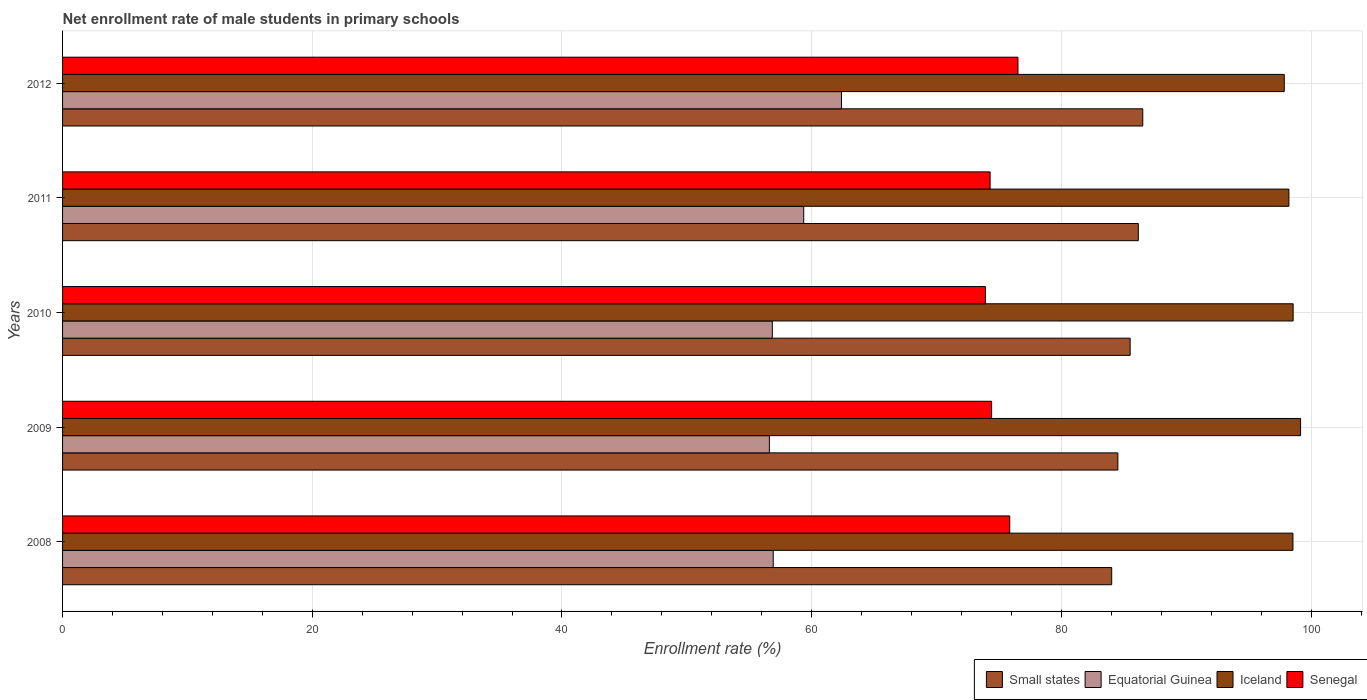How many different coloured bars are there?
Your answer should be very brief. 4. How many groups of bars are there?
Keep it short and to the point. 5. What is the label of the 3rd group of bars from the top?
Your response must be concise. 2010. In how many cases, is the number of bars for a given year not equal to the number of legend labels?
Give a very brief answer. 0. What is the net enrollment rate of male students in primary schools in Small states in 2010?
Ensure brevity in your answer.  85.51. Across all years, what is the maximum net enrollment rate of male students in primary schools in Equatorial Guinea?
Offer a terse response. 62.39. Across all years, what is the minimum net enrollment rate of male students in primary schools in Iceland?
Your answer should be very brief. 97.85. What is the total net enrollment rate of male students in primary schools in Iceland in the graph?
Provide a succinct answer. 492.33. What is the difference between the net enrollment rate of male students in primary schools in Iceland in 2008 and that in 2009?
Offer a very short reply. -0.61. What is the difference between the net enrollment rate of male students in primary schools in Equatorial Guinea in 2010 and the net enrollment rate of male students in primary schools in Iceland in 2008?
Give a very brief answer. -41.7. What is the average net enrollment rate of male students in primary schools in Iceland per year?
Your answer should be compact. 98.47. In the year 2011, what is the difference between the net enrollment rate of male students in primary schools in Equatorial Guinea and net enrollment rate of male students in primary schools in Small states?
Keep it short and to the point. -26.8. What is the ratio of the net enrollment rate of male students in primary schools in Equatorial Guinea in 2008 to that in 2012?
Offer a very short reply. 0.91. Is the net enrollment rate of male students in primary schools in Equatorial Guinea in 2009 less than that in 2011?
Give a very brief answer. Yes. What is the difference between the highest and the second highest net enrollment rate of male students in primary schools in Iceland?
Offer a terse response. 0.6. What is the difference between the highest and the lowest net enrollment rate of male students in primary schools in Small states?
Ensure brevity in your answer.  2.49. In how many years, is the net enrollment rate of male students in primary schools in Small states greater than the average net enrollment rate of male students in primary schools in Small states taken over all years?
Keep it short and to the point. 3. Is the sum of the net enrollment rate of male students in primary schools in Iceland in 2010 and 2011 greater than the maximum net enrollment rate of male students in primary schools in Senegal across all years?
Your response must be concise. Yes. What does the 1st bar from the top in 2011 represents?
Ensure brevity in your answer.  Senegal. What does the 4th bar from the bottom in 2010 represents?
Offer a terse response. Senegal. Is it the case that in every year, the sum of the net enrollment rate of male students in primary schools in Small states and net enrollment rate of male students in primary schools in Iceland is greater than the net enrollment rate of male students in primary schools in Equatorial Guinea?
Offer a terse response. Yes. Are all the bars in the graph horizontal?
Keep it short and to the point. Yes. What is the difference between two consecutive major ticks on the X-axis?
Ensure brevity in your answer.  20. Does the graph contain any zero values?
Your answer should be very brief. No. How are the legend labels stacked?
Your answer should be compact. Horizontal. What is the title of the graph?
Give a very brief answer. Net enrollment rate of male students in primary schools. What is the label or title of the X-axis?
Offer a terse response. Enrollment rate (%). What is the label or title of the Y-axis?
Your response must be concise. Years. What is the Enrollment rate (%) of Small states in 2008?
Keep it short and to the point. 84.03. What is the Enrollment rate (%) of Equatorial Guinea in 2008?
Ensure brevity in your answer.  56.92. What is the Enrollment rate (%) in Iceland in 2008?
Provide a short and direct response. 98.54. What is the Enrollment rate (%) in Senegal in 2008?
Your response must be concise. 75.86. What is the Enrollment rate (%) in Small states in 2009?
Offer a terse response. 84.52. What is the Enrollment rate (%) in Equatorial Guinea in 2009?
Your response must be concise. 56.61. What is the Enrollment rate (%) of Iceland in 2009?
Give a very brief answer. 99.16. What is the Enrollment rate (%) in Senegal in 2009?
Give a very brief answer. 74.41. What is the Enrollment rate (%) in Small states in 2010?
Ensure brevity in your answer.  85.51. What is the Enrollment rate (%) of Equatorial Guinea in 2010?
Ensure brevity in your answer.  56.85. What is the Enrollment rate (%) of Iceland in 2010?
Give a very brief answer. 98.56. What is the Enrollment rate (%) in Senegal in 2010?
Your answer should be very brief. 73.92. What is the Enrollment rate (%) in Small states in 2011?
Your answer should be compact. 86.16. What is the Enrollment rate (%) in Equatorial Guinea in 2011?
Ensure brevity in your answer.  59.36. What is the Enrollment rate (%) of Iceland in 2011?
Ensure brevity in your answer.  98.22. What is the Enrollment rate (%) of Senegal in 2011?
Your response must be concise. 74.29. What is the Enrollment rate (%) in Small states in 2012?
Your response must be concise. 86.52. What is the Enrollment rate (%) of Equatorial Guinea in 2012?
Offer a terse response. 62.39. What is the Enrollment rate (%) in Iceland in 2012?
Give a very brief answer. 97.85. What is the Enrollment rate (%) in Senegal in 2012?
Offer a very short reply. 76.52. Across all years, what is the maximum Enrollment rate (%) in Small states?
Provide a succinct answer. 86.52. Across all years, what is the maximum Enrollment rate (%) of Equatorial Guinea?
Provide a short and direct response. 62.39. Across all years, what is the maximum Enrollment rate (%) of Iceland?
Your response must be concise. 99.16. Across all years, what is the maximum Enrollment rate (%) in Senegal?
Keep it short and to the point. 76.52. Across all years, what is the minimum Enrollment rate (%) in Small states?
Your answer should be very brief. 84.03. Across all years, what is the minimum Enrollment rate (%) of Equatorial Guinea?
Offer a terse response. 56.61. Across all years, what is the minimum Enrollment rate (%) of Iceland?
Your answer should be very brief. 97.85. Across all years, what is the minimum Enrollment rate (%) in Senegal?
Provide a succinct answer. 73.92. What is the total Enrollment rate (%) in Small states in the graph?
Ensure brevity in your answer.  426.73. What is the total Enrollment rate (%) in Equatorial Guinea in the graph?
Ensure brevity in your answer.  292.12. What is the total Enrollment rate (%) of Iceland in the graph?
Make the answer very short. 492.33. What is the total Enrollment rate (%) of Senegal in the graph?
Provide a short and direct response. 375. What is the difference between the Enrollment rate (%) of Small states in 2008 and that in 2009?
Offer a very short reply. -0.49. What is the difference between the Enrollment rate (%) in Equatorial Guinea in 2008 and that in 2009?
Provide a succinct answer. 0.31. What is the difference between the Enrollment rate (%) of Iceland in 2008 and that in 2009?
Give a very brief answer. -0.61. What is the difference between the Enrollment rate (%) of Senegal in 2008 and that in 2009?
Your answer should be compact. 1.45. What is the difference between the Enrollment rate (%) in Small states in 2008 and that in 2010?
Make the answer very short. -1.48. What is the difference between the Enrollment rate (%) in Equatorial Guinea in 2008 and that in 2010?
Your answer should be very brief. 0.07. What is the difference between the Enrollment rate (%) in Iceland in 2008 and that in 2010?
Offer a terse response. -0.02. What is the difference between the Enrollment rate (%) in Senegal in 2008 and that in 2010?
Offer a very short reply. 1.95. What is the difference between the Enrollment rate (%) in Small states in 2008 and that in 2011?
Provide a short and direct response. -2.13. What is the difference between the Enrollment rate (%) in Equatorial Guinea in 2008 and that in 2011?
Keep it short and to the point. -2.44. What is the difference between the Enrollment rate (%) of Iceland in 2008 and that in 2011?
Offer a terse response. 0.32. What is the difference between the Enrollment rate (%) of Senegal in 2008 and that in 2011?
Your response must be concise. 1.57. What is the difference between the Enrollment rate (%) of Small states in 2008 and that in 2012?
Give a very brief answer. -2.49. What is the difference between the Enrollment rate (%) of Equatorial Guinea in 2008 and that in 2012?
Provide a succinct answer. -5.47. What is the difference between the Enrollment rate (%) in Iceland in 2008 and that in 2012?
Ensure brevity in your answer.  0.69. What is the difference between the Enrollment rate (%) of Senegal in 2008 and that in 2012?
Give a very brief answer. -0.66. What is the difference between the Enrollment rate (%) in Small states in 2009 and that in 2010?
Provide a short and direct response. -0.98. What is the difference between the Enrollment rate (%) in Equatorial Guinea in 2009 and that in 2010?
Offer a very short reply. -0.23. What is the difference between the Enrollment rate (%) of Iceland in 2009 and that in 2010?
Make the answer very short. 0.6. What is the difference between the Enrollment rate (%) of Senegal in 2009 and that in 2010?
Keep it short and to the point. 0.49. What is the difference between the Enrollment rate (%) in Small states in 2009 and that in 2011?
Offer a terse response. -1.64. What is the difference between the Enrollment rate (%) of Equatorial Guinea in 2009 and that in 2011?
Keep it short and to the point. -2.75. What is the difference between the Enrollment rate (%) of Iceland in 2009 and that in 2011?
Give a very brief answer. 0.94. What is the difference between the Enrollment rate (%) of Senegal in 2009 and that in 2011?
Your answer should be very brief. 0.12. What is the difference between the Enrollment rate (%) of Small states in 2009 and that in 2012?
Provide a short and direct response. -1.99. What is the difference between the Enrollment rate (%) of Equatorial Guinea in 2009 and that in 2012?
Give a very brief answer. -5.77. What is the difference between the Enrollment rate (%) of Iceland in 2009 and that in 2012?
Offer a terse response. 1.31. What is the difference between the Enrollment rate (%) of Senegal in 2009 and that in 2012?
Provide a succinct answer. -2.11. What is the difference between the Enrollment rate (%) of Small states in 2010 and that in 2011?
Your answer should be very brief. -0.65. What is the difference between the Enrollment rate (%) in Equatorial Guinea in 2010 and that in 2011?
Offer a very short reply. -2.52. What is the difference between the Enrollment rate (%) of Iceland in 2010 and that in 2011?
Your response must be concise. 0.34. What is the difference between the Enrollment rate (%) of Senegal in 2010 and that in 2011?
Ensure brevity in your answer.  -0.38. What is the difference between the Enrollment rate (%) in Small states in 2010 and that in 2012?
Provide a short and direct response. -1.01. What is the difference between the Enrollment rate (%) of Equatorial Guinea in 2010 and that in 2012?
Offer a terse response. -5.54. What is the difference between the Enrollment rate (%) of Iceland in 2010 and that in 2012?
Provide a succinct answer. 0.71. What is the difference between the Enrollment rate (%) in Senegal in 2010 and that in 2012?
Offer a very short reply. -2.6. What is the difference between the Enrollment rate (%) of Small states in 2011 and that in 2012?
Offer a terse response. -0.36. What is the difference between the Enrollment rate (%) in Equatorial Guinea in 2011 and that in 2012?
Ensure brevity in your answer.  -3.02. What is the difference between the Enrollment rate (%) in Iceland in 2011 and that in 2012?
Offer a very short reply. 0.37. What is the difference between the Enrollment rate (%) of Senegal in 2011 and that in 2012?
Provide a succinct answer. -2.23. What is the difference between the Enrollment rate (%) in Small states in 2008 and the Enrollment rate (%) in Equatorial Guinea in 2009?
Your answer should be very brief. 27.42. What is the difference between the Enrollment rate (%) of Small states in 2008 and the Enrollment rate (%) of Iceland in 2009?
Make the answer very short. -15.13. What is the difference between the Enrollment rate (%) of Small states in 2008 and the Enrollment rate (%) of Senegal in 2009?
Offer a very short reply. 9.62. What is the difference between the Enrollment rate (%) of Equatorial Guinea in 2008 and the Enrollment rate (%) of Iceland in 2009?
Provide a short and direct response. -42.24. What is the difference between the Enrollment rate (%) of Equatorial Guinea in 2008 and the Enrollment rate (%) of Senegal in 2009?
Provide a short and direct response. -17.49. What is the difference between the Enrollment rate (%) in Iceland in 2008 and the Enrollment rate (%) in Senegal in 2009?
Your answer should be compact. 24.14. What is the difference between the Enrollment rate (%) in Small states in 2008 and the Enrollment rate (%) in Equatorial Guinea in 2010?
Your answer should be very brief. 27.18. What is the difference between the Enrollment rate (%) of Small states in 2008 and the Enrollment rate (%) of Iceland in 2010?
Provide a short and direct response. -14.53. What is the difference between the Enrollment rate (%) in Small states in 2008 and the Enrollment rate (%) in Senegal in 2010?
Your answer should be very brief. 10.11. What is the difference between the Enrollment rate (%) of Equatorial Guinea in 2008 and the Enrollment rate (%) of Iceland in 2010?
Give a very brief answer. -41.64. What is the difference between the Enrollment rate (%) in Equatorial Guinea in 2008 and the Enrollment rate (%) in Senegal in 2010?
Offer a terse response. -17. What is the difference between the Enrollment rate (%) in Iceland in 2008 and the Enrollment rate (%) in Senegal in 2010?
Give a very brief answer. 24.63. What is the difference between the Enrollment rate (%) of Small states in 2008 and the Enrollment rate (%) of Equatorial Guinea in 2011?
Your answer should be very brief. 24.67. What is the difference between the Enrollment rate (%) of Small states in 2008 and the Enrollment rate (%) of Iceland in 2011?
Your response must be concise. -14.19. What is the difference between the Enrollment rate (%) in Small states in 2008 and the Enrollment rate (%) in Senegal in 2011?
Offer a terse response. 9.74. What is the difference between the Enrollment rate (%) of Equatorial Guinea in 2008 and the Enrollment rate (%) of Iceland in 2011?
Your answer should be very brief. -41.3. What is the difference between the Enrollment rate (%) in Equatorial Guinea in 2008 and the Enrollment rate (%) in Senegal in 2011?
Keep it short and to the point. -17.37. What is the difference between the Enrollment rate (%) of Iceland in 2008 and the Enrollment rate (%) of Senegal in 2011?
Your response must be concise. 24.25. What is the difference between the Enrollment rate (%) of Small states in 2008 and the Enrollment rate (%) of Equatorial Guinea in 2012?
Keep it short and to the point. 21.64. What is the difference between the Enrollment rate (%) of Small states in 2008 and the Enrollment rate (%) of Iceland in 2012?
Keep it short and to the point. -13.82. What is the difference between the Enrollment rate (%) in Small states in 2008 and the Enrollment rate (%) in Senegal in 2012?
Provide a short and direct response. 7.51. What is the difference between the Enrollment rate (%) in Equatorial Guinea in 2008 and the Enrollment rate (%) in Iceland in 2012?
Your answer should be compact. -40.93. What is the difference between the Enrollment rate (%) of Equatorial Guinea in 2008 and the Enrollment rate (%) of Senegal in 2012?
Make the answer very short. -19.6. What is the difference between the Enrollment rate (%) of Iceland in 2008 and the Enrollment rate (%) of Senegal in 2012?
Your answer should be compact. 22.02. What is the difference between the Enrollment rate (%) of Small states in 2009 and the Enrollment rate (%) of Equatorial Guinea in 2010?
Offer a terse response. 27.68. What is the difference between the Enrollment rate (%) of Small states in 2009 and the Enrollment rate (%) of Iceland in 2010?
Your answer should be very brief. -14.04. What is the difference between the Enrollment rate (%) of Small states in 2009 and the Enrollment rate (%) of Senegal in 2010?
Make the answer very short. 10.61. What is the difference between the Enrollment rate (%) of Equatorial Guinea in 2009 and the Enrollment rate (%) of Iceland in 2010?
Your response must be concise. -41.95. What is the difference between the Enrollment rate (%) in Equatorial Guinea in 2009 and the Enrollment rate (%) in Senegal in 2010?
Give a very brief answer. -17.31. What is the difference between the Enrollment rate (%) of Iceland in 2009 and the Enrollment rate (%) of Senegal in 2010?
Offer a terse response. 25.24. What is the difference between the Enrollment rate (%) in Small states in 2009 and the Enrollment rate (%) in Equatorial Guinea in 2011?
Make the answer very short. 25.16. What is the difference between the Enrollment rate (%) in Small states in 2009 and the Enrollment rate (%) in Iceland in 2011?
Your answer should be compact. -13.7. What is the difference between the Enrollment rate (%) in Small states in 2009 and the Enrollment rate (%) in Senegal in 2011?
Give a very brief answer. 10.23. What is the difference between the Enrollment rate (%) of Equatorial Guinea in 2009 and the Enrollment rate (%) of Iceland in 2011?
Your answer should be very brief. -41.61. What is the difference between the Enrollment rate (%) in Equatorial Guinea in 2009 and the Enrollment rate (%) in Senegal in 2011?
Provide a succinct answer. -17.68. What is the difference between the Enrollment rate (%) of Iceland in 2009 and the Enrollment rate (%) of Senegal in 2011?
Keep it short and to the point. 24.87. What is the difference between the Enrollment rate (%) in Small states in 2009 and the Enrollment rate (%) in Equatorial Guinea in 2012?
Your answer should be compact. 22.14. What is the difference between the Enrollment rate (%) of Small states in 2009 and the Enrollment rate (%) of Iceland in 2012?
Your response must be concise. -13.33. What is the difference between the Enrollment rate (%) of Small states in 2009 and the Enrollment rate (%) of Senegal in 2012?
Keep it short and to the point. 8. What is the difference between the Enrollment rate (%) in Equatorial Guinea in 2009 and the Enrollment rate (%) in Iceland in 2012?
Your answer should be compact. -41.24. What is the difference between the Enrollment rate (%) in Equatorial Guinea in 2009 and the Enrollment rate (%) in Senegal in 2012?
Your answer should be compact. -19.91. What is the difference between the Enrollment rate (%) of Iceland in 2009 and the Enrollment rate (%) of Senegal in 2012?
Provide a short and direct response. 22.64. What is the difference between the Enrollment rate (%) in Small states in 2010 and the Enrollment rate (%) in Equatorial Guinea in 2011?
Give a very brief answer. 26.15. What is the difference between the Enrollment rate (%) in Small states in 2010 and the Enrollment rate (%) in Iceland in 2011?
Make the answer very short. -12.71. What is the difference between the Enrollment rate (%) of Small states in 2010 and the Enrollment rate (%) of Senegal in 2011?
Provide a succinct answer. 11.21. What is the difference between the Enrollment rate (%) of Equatorial Guinea in 2010 and the Enrollment rate (%) of Iceland in 2011?
Ensure brevity in your answer.  -41.38. What is the difference between the Enrollment rate (%) of Equatorial Guinea in 2010 and the Enrollment rate (%) of Senegal in 2011?
Provide a succinct answer. -17.45. What is the difference between the Enrollment rate (%) of Iceland in 2010 and the Enrollment rate (%) of Senegal in 2011?
Make the answer very short. 24.27. What is the difference between the Enrollment rate (%) of Small states in 2010 and the Enrollment rate (%) of Equatorial Guinea in 2012?
Make the answer very short. 23.12. What is the difference between the Enrollment rate (%) in Small states in 2010 and the Enrollment rate (%) in Iceland in 2012?
Ensure brevity in your answer.  -12.34. What is the difference between the Enrollment rate (%) of Small states in 2010 and the Enrollment rate (%) of Senegal in 2012?
Your response must be concise. 8.99. What is the difference between the Enrollment rate (%) of Equatorial Guinea in 2010 and the Enrollment rate (%) of Iceland in 2012?
Your answer should be compact. -41.01. What is the difference between the Enrollment rate (%) of Equatorial Guinea in 2010 and the Enrollment rate (%) of Senegal in 2012?
Provide a succinct answer. -19.68. What is the difference between the Enrollment rate (%) of Iceland in 2010 and the Enrollment rate (%) of Senegal in 2012?
Your answer should be very brief. 22.04. What is the difference between the Enrollment rate (%) in Small states in 2011 and the Enrollment rate (%) in Equatorial Guinea in 2012?
Offer a terse response. 23.77. What is the difference between the Enrollment rate (%) of Small states in 2011 and the Enrollment rate (%) of Iceland in 2012?
Give a very brief answer. -11.69. What is the difference between the Enrollment rate (%) in Small states in 2011 and the Enrollment rate (%) in Senegal in 2012?
Make the answer very short. 9.64. What is the difference between the Enrollment rate (%) in Equatorial Guinea in 2011 and the Enrollment rate (%) in Iceland in 2012?
Keep it short and to the point. -38.49. What is the difference between the Enrollment rate (%) of Equatorial Guinea in 2011 and the Enrollment rate (%) of Senegal in 2012?
Keep it short and to the point. -17.16. What is the difference between the Enrollment rate (%) of Iceland in 2011 and the Enrollment rate (%) of Senegal in 2012?
Your answer should be compact. 21.7. What is the average Enrollment rate (%) of Small states per year?
Offer a very short reply. 85.35. What is the average Enrollment rate (%) in Equatorial Guinea per year?
Provide a succinct answer. 58.42. What is the average Enrollment rate (%) of Iceland per year?
Make the answer very short. 98.47. What is the average Enrollment rate (%) in Senegal per year?
Your answer should be compact. 75. In the year 2008, what is the difference between the Enrollment rate (%) in Small states and Enrollment rate (%) in Equatorial Guinea?
Your answer should be compact. 27.11. In the year 2008, what is the difference between the Enrollment rate (%) in Small states and Enrollment rate (%) in Iceland?
Your answer should be very brief. -14.52. In the year 2008, what is the difference between the Enrollment rate (%) in Small states and Enrollment rate (%) in Senegal?
Make the answer very short. 8.17. In the year 2008, what is the difference between the Enrollment rate (%) of Equatorial Guinea and Enrollment rate (%) of Iceland?
Offer a terse response. -41.63. In the year 2008, what is the difference between the Enrollment rate (%) of Equatorial Guinea and Enrollment rate (%) of Senegal?
Offer a very short reply. -18.94. In the year 2008, what is the difference between the Enrollment rate (%) in Iceland and Enrollment rate (%) in Senegal?
Make the answer very short. 22.68. In the year 2009, what is the difference between the Enrollment rate (%) in Small states and Enrollment rate (%) in Equatorial Guinea?
Offer a terse response. 27.91. In the year 2009, what is the difference between the Enrollment rate (%) of Small states and Enrollment rate (%) of Iceland?
Make the answer very short. -14.63. In the year 2009, what is the difference between the Enrollment rate (%) in Small states and Enrollment rate (%) in Senegal?
Provide a short and direct response. 10.11. In the year 2009, what is the difference between the Enrollment rate (%) in Equatorial Guinea and Enrollment rate (%) in Iceland?
Provide a short and direct response. -42.55. In the year 2009, what is the difference between the Enrollment rate (%) of Equatorial Guinea and Enrollment rate (%) of Senegal?
Give a very brief answer. -17.8. In the year 2009, what is the difference between the Enrollment rate (%) in Iceland and Enrollment rate (%) in Senegal?
Make the answer very short. 24.75. In the year 2010, what is the difference between the Enrollment rate (%) in Small states and Enrollment rate (%) in Equatorial Guinea?
Offer a very short reply. 28.66. In the year 2010, what is the difference between the Enrollment rate (%) in Small states and Enrollment rate (%) in Iceland?
Provide a short and direct response. -13.05. In the year 2010, what is the difference between the Enrollment rate (%) of Small states and Enrollment rate (%) of Senegal?
Your answer should be very brief. 11.59. In the year 2010, what is the difference between the Enrollment rate (%) of Equatorial Guinea and Enrollment rate (%) of Iceland?
Ensure brevity in your answer.  -41.72. In the year 2010, what is the difference between the Enrollment rate (%) in Equatorial Guinea and Enrollment rate (%) in Senegal?
Your answer should be compact. -17.07. In the year 2010, what is the difference between the Enrollment rate (%) in Iceland and Enrollment rate (%) in Senegal?
Offer a terse response. 24.64. In the year 2011, what is the difference between the Enrollment rate (%) of Small states and Enrollment rate (%) of Equatorial Guinea?
Your response must be concise. 26.8. In the year 2011, what is the difference between the Enrollment rate (%) of Small states and Enrollment rate (%) of Iceland?
Provide a succinct answer. -12.06. In the year 2011, what is the difference between the Enrollment rate (%) of Small states and Enrollment rate (%) of Senegal?
Your answer should be compact. 11.87. In the year 2011, what is the difference between the Enrollment rate (%) in Equatorial Guinea and Enrollment rate (%) in Iceland?
Make the answer very short. -38.86. In the year 2011, what is the difference between the Enrollment rate (%) in Equatorial Guinea and Enrollment rate (%) in Senegal?
Your answer should be compact. -14.93. In the year 2011, what is the difference between the Enrollment rate (%) of Iceland and Enrollment rate (%) of Senegal?
Give a very brief answer. 23.93. In the year 2012, what is the difference between the Enrollment rate (%) of Small states and Enrollment rate (%) of Equatorial Guinea?
Your response must be concise. 24.13. In the year 2012, what is the difference between the Enrollment rate (%) in Small states and Enrollment rate (%) in Iceland?
Ensure brevity in your answer.  -11.33. In the year 2012, what is the difference between the Enrollment rate (%) in Small states and Enrollment rate (%) in Senegal?
Keep it short and to the point. 9.99. In the year 2012, what is the difference between the Enrollment rate (%) in Equatorial Guinea and Enrollment rate (%) in Iceland?
Your answer should be very brief. -35.47. In the year 2012, what is the difference between the Enrollment rate (%) of Equatorial Guinea and Enrollment rate (%) of Senegal?
Your answer should be very brief. -14.14. In the year 2012, what is the difference between the Enrollment rate (%) in Iceland and Enrollment rate (%) in Senegal?
Keep it short and to the point. 21.33. What is the ratio of the Enrollment rate (%) in Equatorial Guinea in 2008 to that in 2009?
Offer a very short reply. 1.01. What is the ratio of the Enrollment rate (%) of Iceland in 2008 to that in 2009?
Offer a terse response. 0.99. What is the ratio of the Enrollment rate (%) in Senegal in 2008 to that in 2009?
Give a very brief answer. 1.02. What is the ratio of the Enrollment rate (%) of Small states in 2008 to that in 2010?
Provide a short and direct response. 0.98. What is the ratio of the Enrollment rate (%) in Iceland in 2008 to that in 2010?
Your answer should be very brief. 1. What is the ratio of the Enrollment rate (%) in Senegal in 2008 to that in 2010?
Keep it short and to the point. 1.03. What is the ratio of the Enrollment rate (%) in Small states in 2008 to that in 2011?
Your answer should be compact. 0.98. What is the ratio of the Enrollment rate (%) in Equatorial Guinea in 2008 to that in 2011?
Provide a succinct answer. 0.96. What is the ratio of the Enrollment rate (%) of Iceland in 2008 to that in 2011?
Offer a very short reply. 1. What is the ratio of the Enrollment rate (%) of Senegal in 2008 to that in 2011?
Your answer should be compact. 1.02. What is the ratio of the Enrollment rate (%) in Small states in 2008 to that in 2012?
Offer a very short reply. 0.97. What is the ratio of the Enrollment rate (%) of Equatorial Guinea in 2008 to that in 2012?
Provide a short and direct response. 0.91. What is the ratio of the Enrollment rate (%) of Iceland in 2008 to that in 2012?
Your answer should be very brief. 1.01. What is the ratio of the Enrollment rate (%) of Small states in 2009 to that in 2010?
Make the answer very short. 0.99. What is the ratio of the Enrollment rate (%) of Equatorial Guinea in 2009 to that in 2010?
Provide a short and direct response. 1. What is the ratio of the Enrollment rate (%) of Small states in 2009 to that in 2011?
Offer a terse response. 0.98. What is the ratio of the Enrollment rate (%) in Equatorial Guinea in 2009 to that in 2011?
Your response must be concise. 0.95. What is the ratio of the Enrollment rate (%) in Iceland in 2009 to that in 2011?
Provide a succinct answer. 1.01. What is the ratio of the Enrollment rate (%) in Small states in 2009 to that in 2012?
Make the answer very short. 0.98. What is the ratio of the Enrollment rate (%) of Equatorial Guinea in 2009 to that in 2012?
Your answer should be very brief. 0.91. What is the ratio of the Enrollment rate (%) of Iceland in 2009 to that in 2012?
Your answer should be compact. 1.01. What is the ratio of the Enrollment rate (%) of Senegal in 2009 to that in 2012?
Your response must be concise. 0.97. What is the ratio of the Enrollment rate (%) in Equatorial Guinea in 2010 to that in 2011?
Ensure brevity in your answer.  0.96. What is the ratio of the Enrollment rate (%) of Iceland in 2010 to that in 2011?
Offer a terse response. 1. What is the ratio of the Enrollment rate (%) in Small states in 2010 to that in 2012?
Ensure brevity in your answer.  0.99. What is the ratio of the Enrollment rate (%) of Equatorial Guinea in 2010 to that in 2012?
Keep it short and to the point. 0.91. What is the ratio of the Enrollment rate (%) in Iceland in 2010 to that in 2012?
Your answer should be compact. 1.01. What is the ratio of the Enrollment rate (%) in Equatorial Guinea in 2011 to that in 2012?
Your answer should be very brief. 0.95. What is the ratio of the Enrollment rate (%) of Senegal in 2011 to that in 2012?
Provide a succinct answer. 0.97. What is the difference between the highest and the second highest Enrollment rate (%) of Small states?
Your answer should be very brief. 0.36. What is the difference between the highest and the second highest Enrollment rate (%) of Equatorial Guinea?
Provide a succinct answer. 3.02. What is the difference between the highest and the second highest Enrollment rate (%) of Iceland?
Ensure brevity in your answer.  0.6. What is the difference between the highest and the second highest Enrollment rate (%) of Senegal?
Your answer should be very brief. 0.66. What is the difference between the highest and the lowest Enrollment rate (%) of Small states?
Make the answer very short. 2.49. What is the difference between the highest and the lowest Enrollment rate (%) in Equatorial Guinea?
Offer a terse response. 5.77. What is the difference between the highest and the lowest Enrollment rate (%) in Iceland?
Offer a very short reply. 1.31. What is the difference between the highest and the lowest Enrollment rate (%) of Senegal?
Offer a terse response. 2.6. 